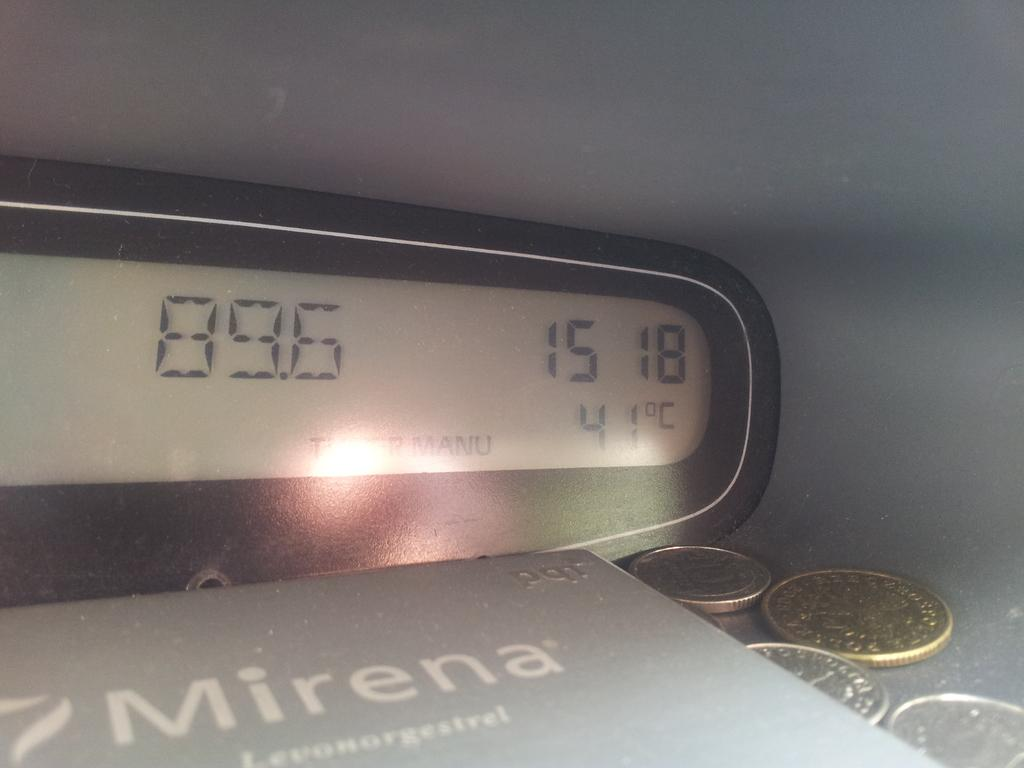<image>
Describe the image concisely. The clock in front of the grey folder states it is 41 outside 